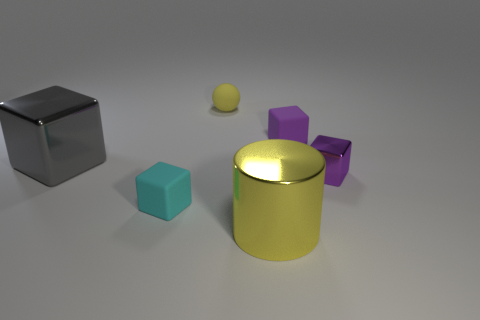Subtract all small shiny blocks. How many blocks are left? 3 Add 1 yellow things. How many objects exist? 7 Subtract all purple blocks. How many blocks are left? 2 Subtract 1 cylinders. How many cylinders are left? 0 Add 1 purple blocks. How many purple blocks are left? 3 Add 2 big blue matte balls. How many big blue matte balls exist? 2 Subtract 0 red cylinders. How many objects are left? 6 Subtract all blocks. How many objects are left? 2 Subtract all red cylinders. Subtract all yellow balls. How many cylinders are left? 1 Subtract all purple spheres. How many cyan cubes are left? 1 